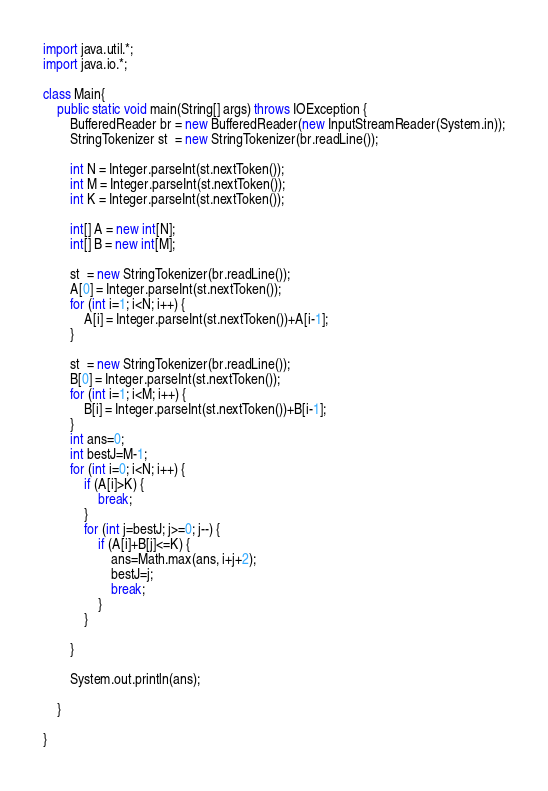Convert code to text. <code><loc_0><loc_0><loc_500><loc_500><_Java_>import java.util.*;
import java.io.*;

class Main{
    public static void main(String[] args) throws IOException {
        BufferedReader br = new BufferedReader(new InputStreamReader(System.in));
        StringTokenizer st  = new StringTokenizer(br.readLine());

        int N = Integer.parseInt(st.nextToken());
        int M = Integer.parseInt(st.nextToken());
        int K = Integer.parseInt(st.nextToken());

        int[] A = new int[N];
        int[] B = new int[M];

        st  = new StringTokenizer(br.readLine());
        A[0] = Integer.parseInt(st.nextToken());
        for (int i=1; i<N; i++) {
            A[i] = Integer.parseInt(st.nextToken())+A[i-1];
        }

        st  = new StringTokenizer(br.readLine());
        B[0] = Integer.parseInt(st.nextToken());
        for (int i=1; i<M; i++) {
            B[i] = Integer.parseInt(st.nextToken())+B[i-1];
        }
        int ans=0;
        int bestJ=M-1;
        for (int i=0; i<N; i++) {
            if (A[i]>K) {
                break;
            }
            for (int j=bestJ; j>=0; j--) {
                if (A[i]+B[j]<=K) {
                    ans=Math.max(ans, i+j+2);
                    bestJ=j;
                    break;
                }
            }

        }

        System.out.println(ans);

    }

}</code> 